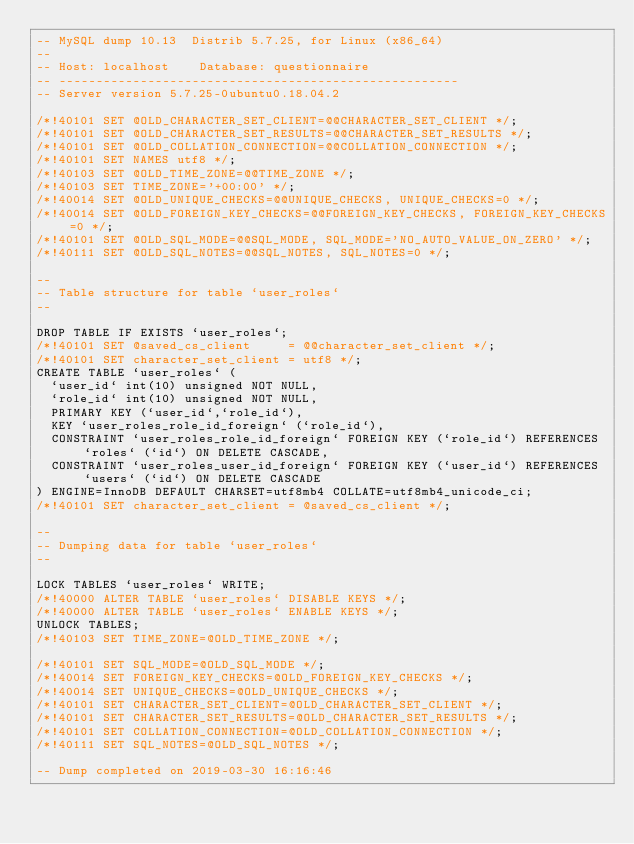Convert code to text. <code><loc_0><loc_0><loc_500><loc_500><_SQL_>-- MySQL dump 10.13  Distrib 5.7.25, for Linux (x86_64)
--
-- Host: localhost    Database: questionnaire
-- ------------------------------------------------------
-- Server version	5.7.25-0ubuntu0.18.04.2

/*!40101 SET @OLD_CHARACTER_SET_CLIENT=@@CHARACTER_SET_CLIENT */;
/*!40101 SET @OLD_CHARACTER_SET_RESULTS=@@CHARACTER_SET_RESULTS */;
/*!40101 SET @OLD_COLLATION_CONNECTION=@@COLLATION_CONNECTION */;
/*!40101 SET NAMES utf8 */;
/*!40103 SET @OLD_TIME_ZONE=@@TIME_ZONE */;
/*!40103 SET TIME_ZONE='+00:00' */;
/*!40014 SET @OLD_UNIQUE_CHECKS=@@UNIQUE_CHECKS, UNIQUE_CHECKS=0 */;
/*!40014 SET @OLD_FOREIGN_KEY_CHECKS=@@FOREIGN_KEY_CHECKS, FOREIGN_KEY_CHECKS=0 */;
/*!40101 SET @OLD_SQL_MODE=@@SQL_MODE, SQL_MODE='NO_AUTO_VALUE_ON_ZERO' */;
/*!40111 SET @OLD_SQL_NOTES=@@SQL_NOTES, SQL_NOTES=0 */;

--
-- Table structure for table `user_roles`
--

DROP TABLE IF EXISTS `user_roles`;
/*!40101 SET @saved_cs_client     = @@character_set_client */;
/*!40101 SET character_set_client = utf8 */;
CREATE TABLE `user_roles` (
  `user_id` int(10) unsigned NOT NULL,
  `role_id` int(10) unsigned NOT NULL,
  PRIMARY KEY (`user_id`,`role_id`),
  KEY `user_roles_role_id_foreign` (`role_id`),
  CONSTRAINT `user_roles_role_id_foreign` FOREIGN KEY (`role_id`) REFERENCES `roles` (`id`) ON DELETE CASCADE,
  CONSTRAINT `user_roles_user_id_foreign` FOREIGN KEY (`user_id`) REFERENCES `users` (`id`) ON DELETE CASCADE
) ENGINE=InnoDB DEFAULT CHARSET=utf8mb4 COLLATE=utf8mb4_unicode_ci;
/*!40101 SET character_set_client = @saved_cs_client */;

--
-- Dumping data for table `user_roles`
--

LOCK TABLES `user_roles` WRITE;
/*!40000 ALTER TABLE `user_roles` DISABLE KEYS */;
/*!40000 ALTER TABLE `user_roles` ENABLE KEYS */;
UNLOCK TABLES;
/*!40103 SET TIME_ZONE=@OLD_TIME_ZONE */;

/*!40101 SET SQL_MODE=@OLD_SQL_MODE */;
/*!40014 SET FOREIGN_KEY_CHECKS=@OLD_FOREIGN_KEY_CHECKS */;
/*!40014 SET UNIQUE_CHECKS=@OLD_UNIQUE_CHECKS */;
/*!40101 SET CHARACTER_SET_CLIENT=@OLD_CHARACTER_SET_CLIENT */;
/*!40101 SET CHARACTER_SET_RESULTS=@OLD_CHARACTER_SET_RESULTS */;
/*!40101 SET COLLATION_CONNECTION=@OLD_COLLATION_CONNECTION */;
/*!40111 SET SQL_NOTES=@OLD_SQL_NOTES */;

-- Dump completed on 2019-03-30 16:16:46
</code> 